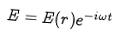Convert formula to latex. <formula><loc_0><loc_0><loc_500><loc_500>E = E ( r ) e ^ { - i \omega t }</formula> 